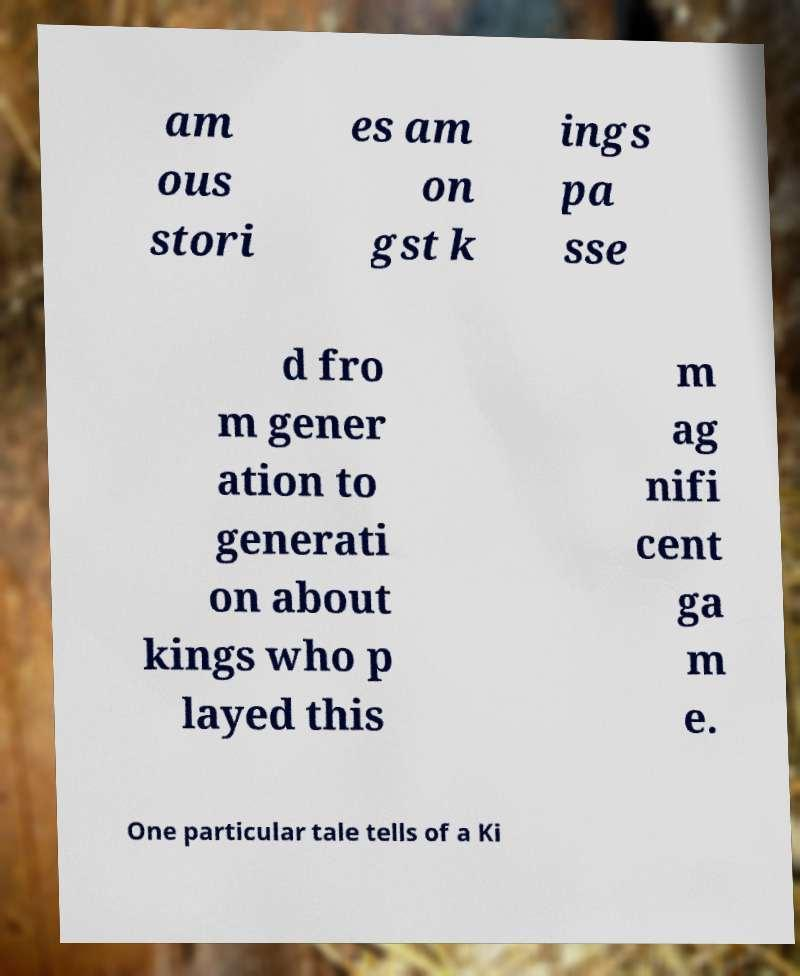Can you accurately transcribe the text from the provided image for me? am ous stori es am on gst k ings pa sse d fro m gener ation to generati on about kings who p layed this m ag nifi cent ga m e. One particular tale tells of a Ki 